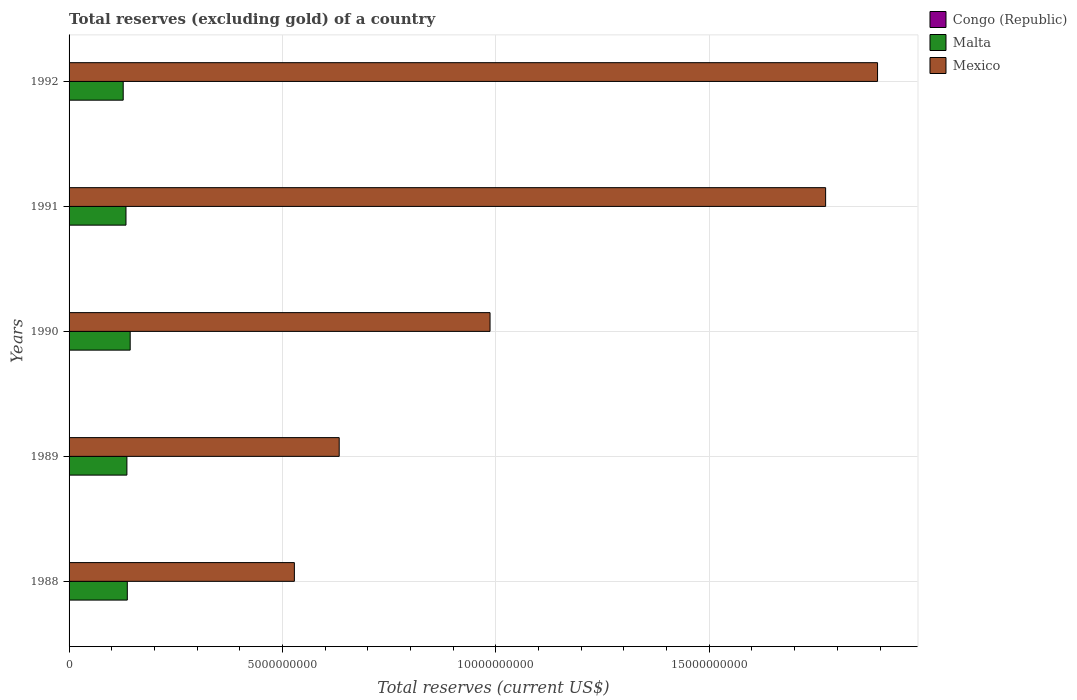How many groups of bars are there?
Your answer should be compact. 5. How many bars are there on the 5th tick from the top?
Offer a terse response. 3. In how many cases, is the number of bars for a given year not equal to the number of legend labels?
Give a very brief answer. 0. What is the total reserves (excluding gold) in Mexico in 1988?
Make the answer very short. 5.28e+09. Across all years, what is the maximum total reserves (excluding gold) in Congo (Republic)?
Make the answer very short. 6.10e+06. Across all years, what is the minimum total reserves (excluding gold) in Mexico?
Give a very brief answer. 5.28e+09. What is the total total reserves (excluding gold) in Congo (Republic) in the graph?
Keep it short and to the point. 2.55e+07. What is the difference between the total reserves (excluding gold) in Mexico in 1989 and that in 1992?
Your answer should be compact. -1.26e+1. What is the difference between the total reserves (excluding gold) in Malta in 1988 and the total reserves (excluding gold) in Congo (Republic) in 1991?
Offer a very short reply. 1.36e+09. What is the average total reserves (excluding gold) in Malta per year?
Ensure brevity in your answer.  1.35e+09. In the year 1991, what is the difference between the total reserves (excluding gold) in Malta and total reserves (excluding gold) in Congo (Republic)?
Ensure brevity in your answer.  1.33e+09. What is the ratio of the total reserves (excluding gold) in Malta in 1990 to that in 1991?
Your response must be concise. 1.07. Is the total reserves (excluding gold) in Mexico in 1989 less than that in 1991?
Give a very brief answer. Yes. What is the difference between the highest and the second highest total reserves (excluding gold) in Congo (Republic)?
Your answer should be very brief. 1.92e+05. What is the difference between the highest and the lowest total reserves (excluding gold) in Congo (Republic)?
Provide a succinct answer. 2.09e+06. In how many years, is the total reserves (excluding gold) in Congo (Republic) greater than the average total reserves (excluding gold) in Congo (Republic) taken over all years?
Make the answer very short. 2. What does the 3rd bar from the top in 1988 represents?
Offer a terse response. Congo (Republic). What does the 1st bar from the bottom in 1992 represents?
Your answer should be compact. Congo (Republic). Is it the case that in every year, the sum of the total reserves (excluding gold) in Congo (Republic) and total reserves (excluding gold) in Malta is greater than the total reserves (excluding gold) in Mexico?
Your response must be concise. No. How many bars are there?
Your answer should be very brief. 15. How many years are there in the graph?
Offer a terse response. 5. What is the difference between two consecutive major ticks on the X-axis?
Keep it short and to the point. 5.00e+09. Are the values on the major ticks of X-axis written in scientific E-notation?
Provide a short and direct response. No. Does the graph contain any zero values?
Your response must be concise. No. Does the graph contain grids?
Keep it short and to the point. Yes. Where does the legend appear in the graph?
Give a very brief answer. Top right. How many legend labels are there?
Your answer should be very brief. 3. What is the title of the graph?
Offer a terse response. Total reserves (excluding gold) of a country. Does "European Union" appear as one of the legend labels in the graph?
Your response must be concise. No. What is the label or title of the X-axis?
Your answer should be very brief. Total reserves (current US$). What is the label or title of the Y-axis?
Make the answer very short. Years. What is the Total reserves (current US$) in Congo (Republic) in 1988?
Your answer should be very brief. 4.70e+06. What is the Total reserves (current US$) of Malta in 1988?
Your answer should be compact. 1.36e+09. What is the Total reserves (current US$) in Mexico in 1988?
Offer a very short reply. 5.28e+09. What is the Total reserves (current US$) in Congo (Republic) in 1989?
Your answer should be compact. 6.10e+06. What is the Total reserves (current US$) in Malta in 1989?
Provide a short and direct response. 1.36e+09. What is the Total reserves (current US$) in Mexico in 1989?
Provide a succinct answer. 6.33e+09. What is the Total reserves (current US$) of Congo (Republic) in 1990?
Offer a very short reply. 5.91e+06. What is the Total reserves (current US$) in Malta in 1990?
Give a very brief answer. 1.43e+09. What is the Total reserves (current US$) in Mexico in 1990?
Your response must be concise. 9.86e+09. What is the Total reserves (current US$) in Congo (Republic) in 1991?
Your answer should be compact. 4.76e+06. What is the Total reserves (current US$) in Malta in 1991?
Offer a very short reply. 1.33e+09. What is the Total reserves (current US$) of Mexico in 1991?
Your answer should be very brief. 1.77e+1. What is the Total reserves (current US$) in Congo (Republic) in 1992?
Provide a short and direct response. 4.01e+06. What is the Total reserves (current US$) in Malta in 1992?
Your response must be concise. 1.27e+09. What is the Total reserves (current US$) in Mexico in 1992?
Give a very brief answer. 1.89e+1. Across all years, what is the maximum Total reserves (current US$) of Congo (Republic)?
Provide a succinct answer. 6.10e+06. Across all years, what is the maximum Total reserves (current US$) in Malta?
Ensure brevity in your answer.  1.43e+09. Across all years, what is the maximum Total reserves (current US$) in Mexico?
Offer a very short reply. 1.89e+1. Across all years, what is the minimum Total reserves (current US$) of Congo (Republic)?
Provide a succinct answer. 4.01e+06. Across all years, what is the minimum Total reserves (current US$) in Malta?
Ensure brevity in your answer.  1.27e+09. Across all years, what is the minimum Total reserves (current US$) in Mexico?
Your answer should be compact. 5.28e+09. What is the total Total reserves (current US$) in Congo (Republic) in the graph?
Provide a short and direct response. 2.55e+07. What is the total Total reserves (current US$) of Malta in the graph?
Make the answer very short. 6.75e+09. What is the total Total reserves (current US$) in Mexico in the graph?
Your answer should be compact. 5.81e+1. What is the difference between the Total reserves (current US$) of Congo (Republic) in 1988 and that in 1989?
Keep it short and to the point. -1.40e+06. What is the difference between the Total reserves (current US$) of Malta in 1988 and that in 1989?
Offer a terse response. 9.56e+06. What is the difference between the Total reserves (current US$) of Mexico in 1988 and that in 1989?
Offer a terse response. -1.05e+09. What is the difference between the Total reserves (current US$) of Congo (Republic) in 1988 and that in 1990?
Your answer should be compact. -1.20e+06. What is the difference between the Total reserves (current US$) in Malta in 1988 and that in 1990?
Your answer should be compact. -6.71e+07. What is the difference between the Total reserves (current US$) in Mexico in 1988 and that in 1990?
Offer a terse response. -4.58e+09. What is the difference between the Total reserves (current US$) of Congo (Republic) in 1988 and that in 1991?
Your answer should be compact. -5.62e+04. What is the difference between the Total reserves (current US$) in Malta in 1988 and that in 1991?
Your answer should be compact. 3.14e+07. What is the difference between the Total reserves (current US$) in Mexico in 1988 and that in 1991?
Your answer should be very brief. -1.24e+1. What is the difference between the Total reserves (current US$) of Congo (Republic) in 1988 and that in 1992?
Make the answer very short. 6.98e+05. What is the difference between the Total reserves (current US$) in Malta in 1988 and that in 1992?
Keep it short and to the point. 9.64e+07. What is the difference between the Total reserves (current US$) in Mexico in 1988 and that in 1992?
Ensure brevity in your answer.  -1.37e+1. What is the difference between the Total reserves (current US$) of Congo (Republic) in 1989 and that in 1990?
Offer a very short reply. 1.92e+05. What is the difference between the Total reserves (current US$) of Malta in 1989 and that in 1990?
Offer a terse response. -7.66e+07. What is the difference between the Total reserves (current US$) of Mexico in 1989 and that in 1990?
Your answer should be very brief. -3.53e+09. What is the difference between the Total reserves (current US$) in Congo (Republic) in 1989 and that in 1991?
Provide a short and direct response. 1.34e+06. What is the difference between the Total reserves (current US$) in Malta in 1989 and that in 1991?
Offer a very short reply. 2.19e+07. What is the difference between the Total reserves (current US$) of Mexico in 1989 and that in 1991?
Provide a succinct answer. -1.14e+1. What is the difference between the Total reserves (current US$) of Congo (Republic) in 1989 and that in 1992?
Make the answer very short. 2.09e+06. What is the difference between the Total reserves (current US$) of Malta in 1989 and that in 1992?
Offer a terse response. 8.68e+07. What is the difference between the Total reserves (current US$) in Mexico in 1989 and that in 1992?
Give a very brief answer. -1.26e+1. What is the difference between the Total reserves (current US$) in Congo (Republic) in 1990 and that in 1991?
Give a very brief answer. 1.15e+06. What is the difference between the Total reserves (current US$) of Malta in 1990 and that in 1991?
Your answer should be very brief. 9.85e+07. What is the difference between the Total reserves (current US$) in Mexico in 1990 and that in 1991?
Your answer should be compact. -7.86e+09. What is the difference between the Total reserves (current US$) in Congo (Republic) in 1990 and that in 1992?
Ensure brevity in your answer.  1.90e+06. What is the difference between the Total reserves (current US$) of Malta in 1990 and that in 1992?
Your response must be concise. 1.63e+08. What is the difference between the Total reserves (current US$) in Mexico in 1990 and that in 1992?
Keep it short and to the point. -9.08e+09. What is the difference between the Total reserves (current US$) of Congo (Republic) in 1991 and that in 1992?
Provide a succinct answer. 7.54e+05. What is the difference between the Total reserves (current US$) in Malta in 1991 and that in 1992?
Ensure brevity in your answer.  6.49e+07. What is the difference between the Total reserves (current US$) in Mexico in 1991 and that in 1992?
Your answer should be compact. -1.22e+09. What is the difference between the Total reserves (current US$) in Congo (Republic) in 1988 and the Total reserves (current US$) in Malta in 1989?
Make the answer very short. -1.35e+09. What is the difference between the Total reserves (current US$) in Congo (Republic) in 1988 and the Total reserves (current US$) in Mexico in 1989?
Your response must be concise. -6.32e+09. What is the difference between the Total reserves (current US$) in Malta in 1988 and the Total reserves (current US$) in Mexico in 1989?
Give a very brief answer. -4.96e+09. What is the difference between the Total reserves (current US$) of Congo (Republic) in 1988 and the Total reserves (current US$) of Malta in 1990?
Offer a terse response. -1.43e+09. What is the difference between the Total reserves (current US$) in Congo (Republic) in 1988 and the Total reserves (current US$) in Mexico in 1990?
Your response must be concise. -9.86e+09. What is the difference between the Total reserves (current US$) of Malta in 1988 and the Total reserves (current US$) of Mexico in 1990?
Keep it short and to the point. -8.50e+09. What is the difference between the Total reserves (current US$) in Congo (Republic) in 1988 and the Total reserves (current US$) in Malta in 1991?
Ensure brevity in your answer.  -1.33e+09. What is the difference between the Total reserves (current US$) of Congo (Republic) in 1988 and the Total reserves (current US$) of Mexico in 1991?
Your answer should be very brief. -1.77e+1. What is the difference between the Total reserves (current US$) of Malta in 1988 and the Total reserves (current US$) of Mexico in 1991?
Your answer should be very brief. -1.64e+1. What is the difference between the Total reserves (current US$) in Congo (Republic) in 1988 and the Total reserves (current US$) in Malta in 1992?
Provide a succinct answer. -1.26e+09. What is the difference between the Total reserves (current US$) of Congo (Republic) in 1988 and the Total reserves (current US$) of Mexico in 1992?
Keep it short and to the point. -1.89e+1. What is the difference between the Total reserves (current US$) of Malta in 1988 and the Total reserves (current US$) of Mexico in 1992?
Ensure brevity in your answer.  -1.76e+1. What is the difference between the Total reserves (current US$) of Congo (Republic) in 1989 and the Total reserves (current US$) of Malta in 1990?
Offer a terse response. -1.43e+09. What is the difference between the Total reserves (current US$) in Congo (Republic) in 1989 and the Total reserves (current US$) in Mexico in 1990?
Provide a short and direct response. -9.86e+09. What is the difference between the Total reserves (current US$) of Malta in 1989 and the Total reserves (current US$) of Mexico in 1990?
Your answer should be compact. -8.51e+09. What is the difference between the Total reserves (current US$) of Congo (Republic) in 1989 and the Total reserves (current US$) of Malta in 1991?
Offer a terse response. -1.33e+09. What is the difference between the Total reserves (current US$) in Congo (Republic) in 1989 and the Total reserves (current US$) in Mexico in 1991?
Offer a very short reply. -1.77e+1. What is the difference between the Total reserves (current US$) of Malta in 1989 and the Total reserves (current US$) of Mexico in 1991?
Ensure brevity in your answer.  -1.64e+1. What is the difference between the Total reserves (current US$) in Congo (Republic) in 1989 and the Total reserves (current US$) in Malta in 1992?
Ensure brevity in your answer.  -1.26e+09. What is the difference between the Total reserves (current US$) of Congo (Republic) in 1989 and the Total reserves (current US$) of Mexico in 1992?
Provide a succinct answer. -1.89e+1. What is the difference between the Total reserves (current US$) of Malta in 1989 and the Total reserves (current US$) of Mexico in 1992?
Ensure brevity in your answer.  -1.76e+1. What is the difference between the Total reserves (current US$) in Congo (Republic) in 1990 and the Total reserves (current US$) in Malta in 1991?
Your answer should be compact. -1.33e+09. What is the difference between the Total reserves (current US$) in Congo (Republic) in 1990 and the Total reserves (current US$) in Mexico in 1991?
Provide a succinct answer. -1.77e+1. What is the difference between the Total reserves (current US$) in Malta in 1990 and the Total reserves (current US$) in Mexico in 1991?
Make the answer very short. -1.63e+1. What is the difference between the Total reserves (current US$) of Congo (Republic) in 1990 and the Total reserves (current US$) of Malta in 1992?
Your answer should be compact. -1.26e+09. What is the difference between the Total reserves (current US$) of Congo (Republic) in 1990 and the Total reserves (current US$) of Mexico in 1992?
Your response must be concise. -1.89e+1. What is the difference between the Total reserves (current US$) of Malta in 1990 and the Total reserves (current US$) of Mexico in 1992?
Make the answer very short. -1.75e+1. What is the difference between the Total reserves (current US$) of Congo (Republic) in 1991 and the Total reserves (current US$) of Malta in 1992?
Offer a very short reply. -1.26e+09. What is the difference between the Total reserves (current US$) in Congo (Republic) in 1991 and the Total reserves (current US$) in Mexico in 1992?
Offer a terse response. -1.89e+1. What is the difference between the Total reserves (current US$) of Malta in 1991 and the Total reserves (current US$) of Mexico in 1992?
Offer a terse response. -1.76e+1. What is the average Total reserves (current US$) of Congo (Republic) per year?
Provide a short and direct response. 5.10e+06. What is the average Total reserves (current US$) in Malta per year?
Make the answer very short. 1.35e+09. What is the average Total reserves (current US$) in Mexico per year?
Offer a very short reply. 1.16e+1. In the year 1988, what is the difference between the Total reserves (current US$) of Congo (Republic) and Total reserves (current US$) of Malta?
Give a very brief answer. -1.36e+09. In the year 1988, what is the difference between the Total reserves (current US$) in Congo (Republic) and Total reserves (current US$) in Mexico?
Your answer should be very brief. -5.27e+09. In the year 1988, what is the difference between the Total reserves (current US$) of Malta and Total reserves (current US$) of Mexico?
Provide a succinct answer. -3.91e+09. In the year 1989, what is the difference between the Total reserves (current US$) of Congo (Republic) and Total reserves (current US$) of Malta?
Offer a very short reply. -1.35e+09. In the year 1989, what is the difference between the Total reserves (current US$) in Congo (Republic) and Total reserves (current US$) in Mexico?
Ensure brevity in your answer.  -6.32e+09. In the year 1989, what is the difference between the Total reserves (current US$) of Malta and Total reserves (current US$) of Mexico?
Provide a short and direct response. -4.97e+09. In the year 1990, what is the difference between the Total reserves (current US$) in Congo (Republic) and Total reserves (current US$) in Malta?
Provide a short and direct response. -1.43e+09. In the year 1990, what is the difference between the Total reserves (current US$) in Congo (Republic) and Total reserves (current US$) in Mexico?
Give a very brief answer. -9.86e+09. In the year 1990, what is the difference between the Total reserves (current US$) in Malta and Total reserves (current US$) in Mexico?
Keep it short and to the point. -8.43e+09. In the year 1991, what is the difference between the Total reserves (current US$) of Congo (Republic) and Total reserves (current US$) of Malta?
Your response must be concise. -1.33e+09. In the year 1991, what is the difference between the Total reserves (current US$) of Congo (Republic) and Total reserves (current US$) of Mexico?
Give a very brief answer. -1.77e+1. In the year 1991, what is the difference between the Total reserves (current US$) in Malta and Total reserves (current US$) in Mexico?
Provide a short and direct response. -1.64e+1. In the year 1992, what is the difference between the Total reserves (current US$) in Congo (Republic) and Total reserves (current US$) in Malta?
Make the answer very short. -1.26e+09. In the year 1992, what is the difference between the Total reserves (current US$) of Congo (Republic) and Total reserves (current US$) of Mexico?
Keep it short and to the point. -1.89e+1. In the year 1992, what is the difference between the Total reserves (current US$) of Malta and Total reserves (current US$) of Mexico?
Keep it short and to the point. -1.77e+1. What is the ratio of the Total reserves (current US$) of Congo (Republic) in 1988 to that in 1989?
Ensure brevity in your answer.  0.77. What is the ratio of the Total reserves (current US$) of Malta in 1988 to that in 1989?
Keep it short and to the point. 1.01. What is the ratio of the Total reserves (current US$) of Mexico in 1988 to that in 1989?
Offer a terse response. 0.83. What is the ratio of the Total reserves (current US$) of Congo (Republic) in 1988 to that in 1990?
Offer a terse response. 0.8. What is the ratio of the Total reserves (current US$) of Malta in 1988 to that in 1990?
Give a very brief answer. 0.95. What is the ratio of the Total reserves (current US$) in Mexico in 1988 to that in 1990?
Keep it short and to the point. 0.54. What is the ratio of the Total reserves (current US$) of Congo (Republic) in 1988 to that in 1991?
Your response must be concise. 0.99. What is the ratio of the Total reserves (current US$) in Malta in 1988 to that in 1991?
Your answer should be compact. 1.02. What is the ratio of the Total reserves (current US$) in Mexico in 1988 to that in 1991?
Offer a terse response. 0.3. What is the ratio of the Total reserves (current US$) in Congo (Republic) in 1988 to that in 1992?
Keep it short and to the point. 1.17. What is the ratio of the Total reserves (current US$) in Malta in 1988 to that in 1992?
Your answer should be compact. 1.08. What is the ratio of the Total reserves (current US$) in Mexico in 1988 to that in 1992?
Make the answer very short. 0.28. What is the ratio of the Total reserves (current US$) of Congo (Republic) in 1989 to that in 1990?
Your response must be concise. 1.03. What is the ratio of the Total reserves (current US$) of Malta in 1989 to that in 1990?
Your answer should be compact. 0.95. What is the ratio of the Total reserves (current US$) of Mexico in 1989 to that in 1990?
Your answer should be compact. 0.64. What is the ratio of the Total reserves (current US$) in Congo (Republic) in 1989 to that in 1991?
Your answer should be very brief. 1.28. What is the ratio of the Total reserves (current US$) in Malta in 1989 to that in 1991?
Keep it short and to the point. 1.02. What is the ratio of the Total reserves (current US$) of Mexico in 1989 to that in 1991?
Your response must be concise. 0.36. What is the ratio of the Total reserves (current US$) of Congo (Republic) in 1989 to that in 1992?
Your answer should be compact. 1.52. What is the ratio of the Total reserves (current US$) of Malta in 1989 to that in 1992?
Give a very brief answer. 1.07. What is the ratio of the Total reserves (current US$) of Mexico in 1989 to that in 1992?
Keep it short and to the point. 0.33. What is the ratio of the Total reserves (current US$) of Congo (Republic) in 1990 to that in 1991?
Offer a terse response. 1.24. What is the ratio of the Total reserves (current US$) of Malta in 1990 to that in 1991?
Ensure brevity in your answer.  1.07. What is the ratio of the Total reserves (current US$) in Mexico in 1990 to that in 1991?
Provide a short and direct response. 0.56. What is the ratio of the Total reserves (current US$) in Congo (Republic) in 1990 to that in 1992?
Keep it short and to the point. 1.47. What is the ratio of the Total reserves (current US$) in Malta in 1990 to that in 1992?
Keep it short and to the point. 1.13. What is the ratio of the Total reserves (current US$) of Mexico in 1990 to that in 1992?
Your answer should be very brief. 0.52. What is the ratio of the Total reserves (current US$) of Congo (Republic) in 1991 to that in 1992?
Your answer should be very brief. 1.19. What is the ratio of the Total reserves (current US$) of Malta in 1991 to that in 1992?
Your answer should be very brief. 1.05. What is the ratio of the Total reserves (current US$) in Mexico in 1991 to that in 1992?
Provide a succinct answer. 0.94. What is the difference between the highest and the second highest Total reserves (current US$) of Congo (Republic)?
Your answer should be compact. 1.92e+05. What is the difference between the highest and the second highest Total reserves (current US$) in Malta?
Make the answer very short. 6.71e+07. What is the difference between the highest and the second highest Total reserves (current US$) in Mexico?
Your answer should be very brief. 1.22e+09. What is the difference between the highest and the lowest Total reserves (current US$) in Congo (Republic)?
Give a very brief answer. 2.09e+06. What is the difference between the highest and the lowest Total reserves (current US$) of Malta?
Provide a succinct answer. 1.63e+08. What is the difference between the highest and the lowest Total reserves (current US$) in Mexico?
Make the answer very short. 1.37e+1. 